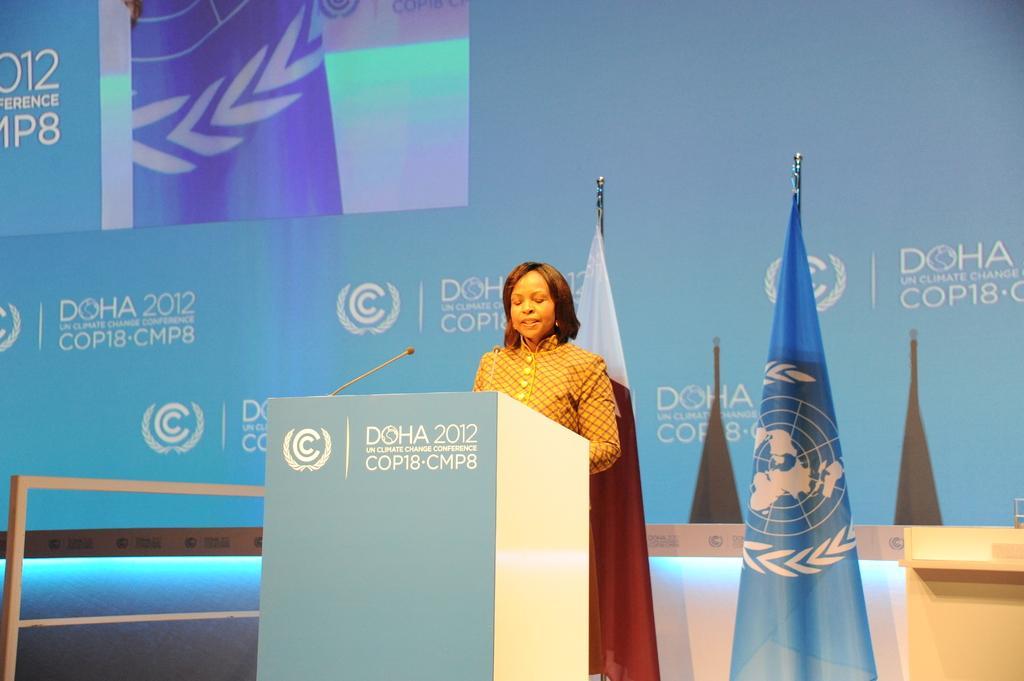Describe this image in one or two sentences. In this image, we can see a person wearing clothes and standing in front of the podium. There are flags in the middle of the image. In the background, we can see some text. 